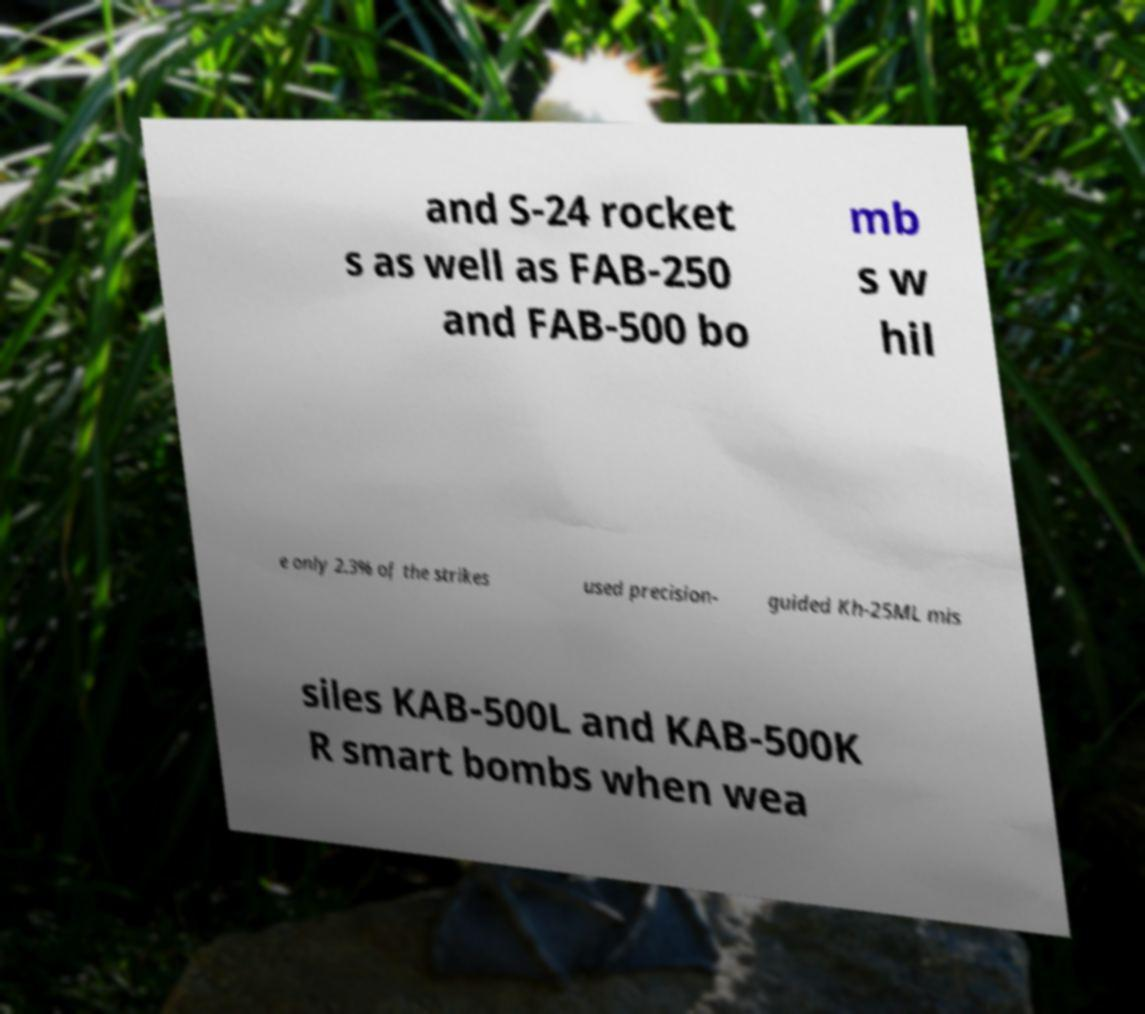For documentation purposes, I need the text within this image transcribed. Could you provide that? and S-24 rocket s as well as FAB-250 and FAB-500 bo mb s w hil e only 2.3% of the strikes used precision- guided Kh-25ML mis siles KAB-500L and KAB-500K R smart bombs when wea 